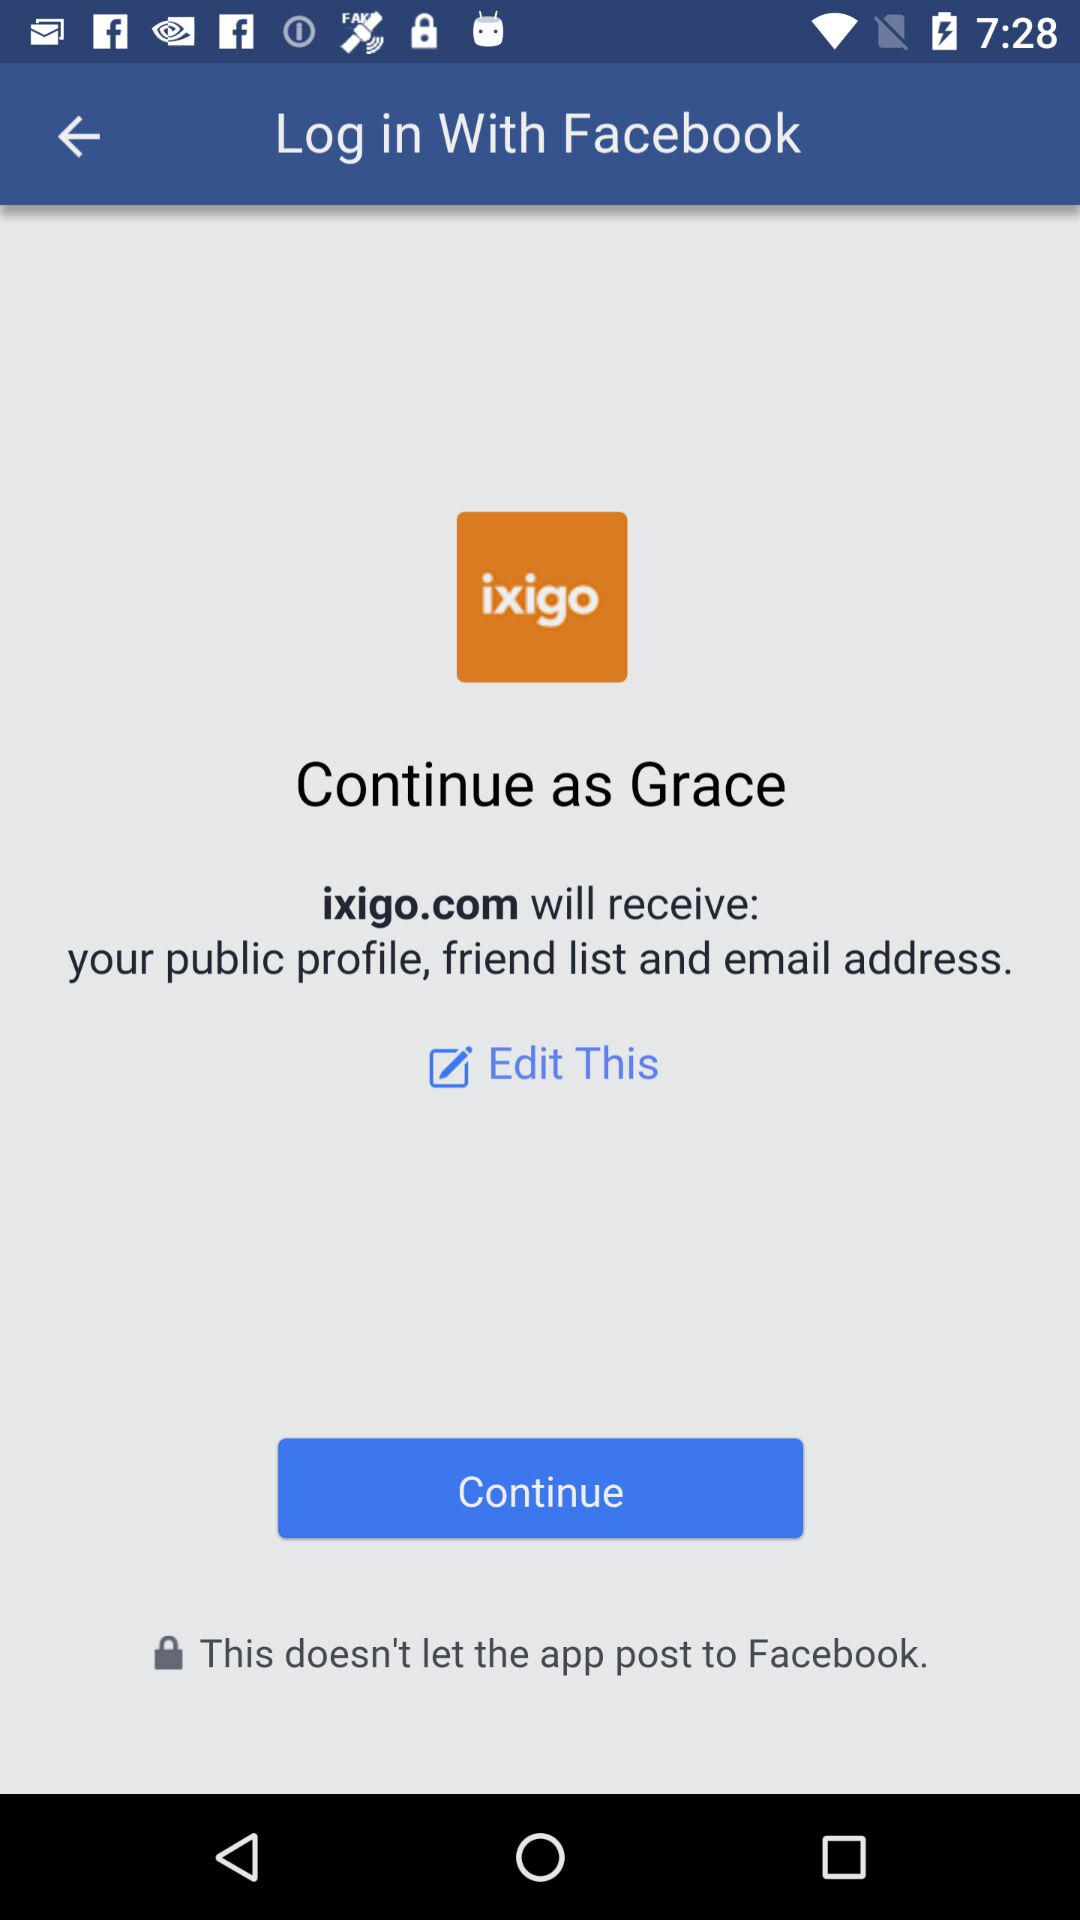What is the user name? The user name is "'Grace". 